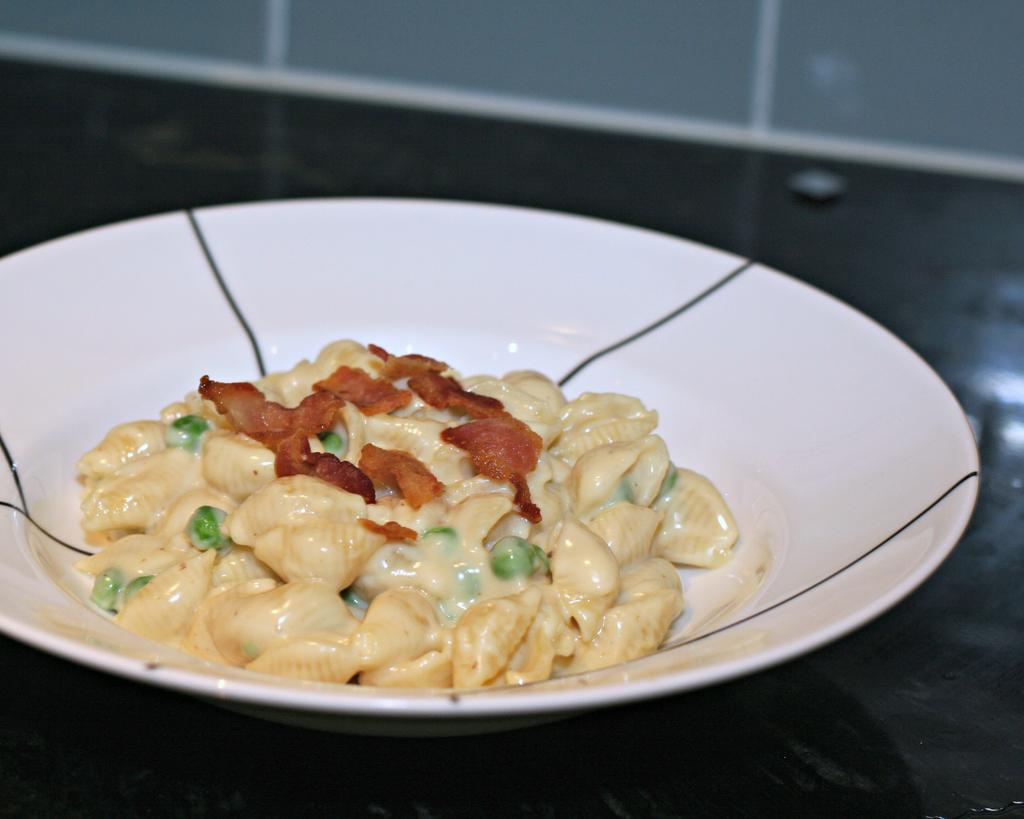What is on the white plate in the image? There is food on the white plate in the image. Where is the plate located? The plate is on a table. What else can be seen on the table surface? There is an object on the surface in the image. How many men are sorting screws in the image? There are no men or screws present in the image. 